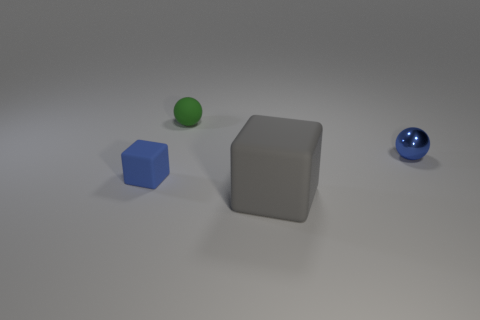Add 1 blue matte objects. How many objects exist? 5 Add 3 brown metallic cubes. How many brown metallic cubes exist? 3 Subtract 1 gray cubes. How many objects are left? 3 Subtract all small brown rubber objects. Subtract all tiny green spheres. How many objects are left? 3 Add 2 cubes. How many cubes are left? 4 